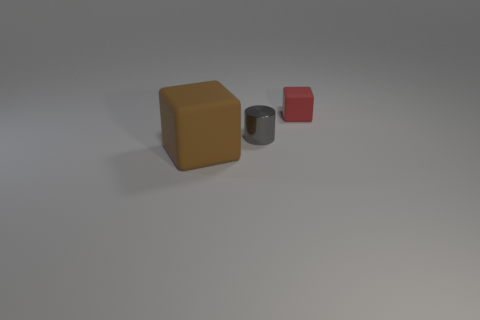Are there any other big cylinders that have the same color as the cylinder?
Offer a very short reply. No. There is a gray shiny thing that is the same size as the red block; what shape is it?
Offer a very short reply. Cylinder. There is a matte object in front of the tiny red cube; does it have the same color as the small metallic cylinder?
Your answer should be compact. No. What number of things are things that are to the right of the large brown matte object or big brown rubber cubes?
Your answer should be compact. 3. Are there more matte blocks that are behind the small gray thing than small gray cylinders that are behind the small red block?
Ensure brevity in your answer.  Yes. Is the material of the red object the same as the brown block?
Offer a terse response. Yes. What shape is the object that is in front of the red block and to the right of the big brown matte object?
Provide a succinct answer. Cylinder. There is a brown object that is the same material as the red cube; what shape is it?
Offer a very short reply. Cube. Are there any small green objects?
Provide a succinct answer. No. Is there a large brown block that is on the right side of the block behind the large brown rubber block?
Keep it short and to the point. No. 